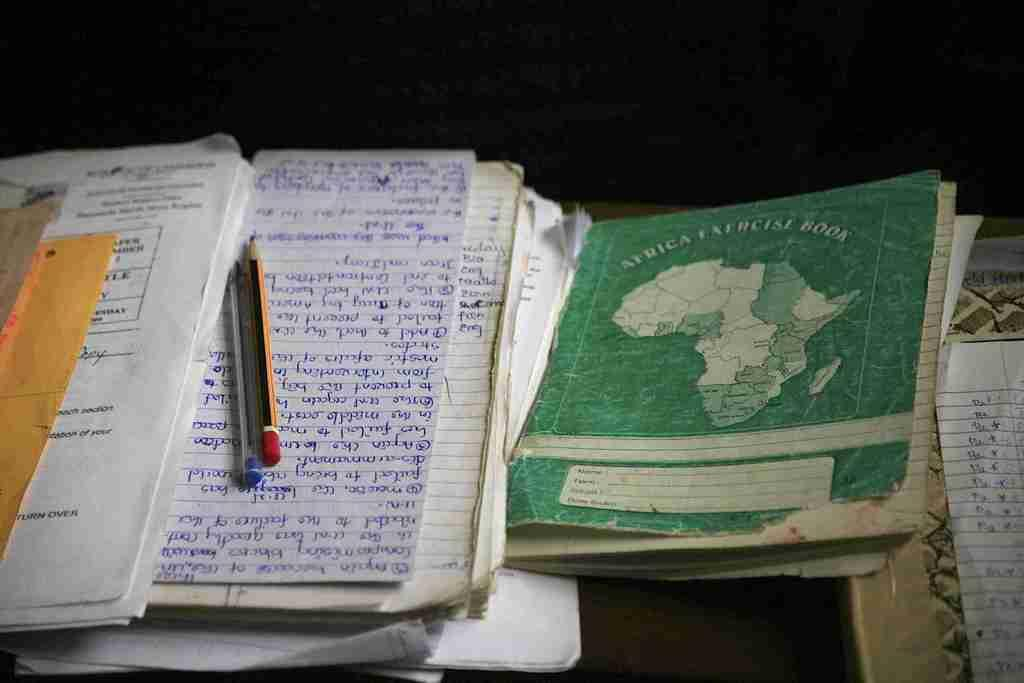<image>
Summarize the visual content of the image. A book entitled Africa Exercise book rests on a table next to a stack of papers. 